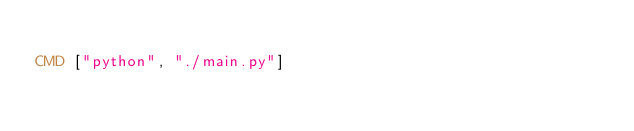<code> <loc_0><loc_0><loc_500><loc_500><_Dockerfile_>
CMD ["python", "./main.py"]
</code> 